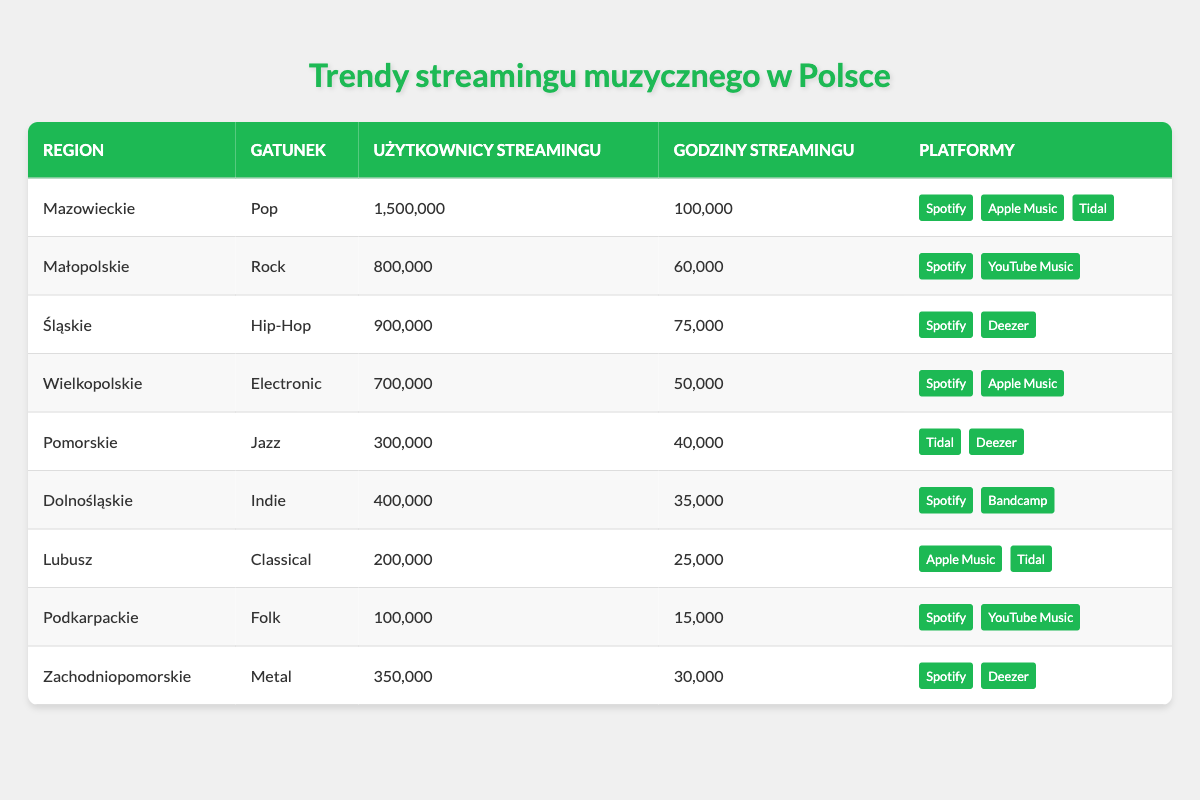What region has the highest number of streaming users? By examining the “Użytkownicy streamingu” column, I find that Mazowieckie has the highest count at 1,500,000 users.
Answer: Mazowieckie How many streaming hours are recorded for Rock music in Małopolskie? Looking at the “Godziny streamingu” column for the region Małopolskie and genre Rock, I see it has 60,000 streaming hours.
Answer: 60,000 What is the total number of streaming users across all regions for Electronic music? I check the table for the genre Electronic, which is found in Wielkopolskie, with 700,000 streaming users. There are no other regions with this genre. Thus, the total remains 700,000.
Answer: 700,000 Which genre has the least number of streaming users in the table? By reviewing the “Użytkownicy streamingu” column, the lowest count is for Folk music in Podkarpackie at 100,000 users.
Answer: Folk Are there more streaming hours for Indie music than for Jazz music? I compare the “Godziny streamingu” for Indie and Jazz genres. Indie has 35,000 hours while Jazz has 40,000 hours. Since 35,000 is less than 40,000, the answer is no.
Answer: No What is the total number of streaming users in the regions that have users for both Spotify and Deezer? The regions with both Spotify and Deezer are Śląskie (900,000) and Zachodniopomorskie (350,000). Adding these gives us 900,000 + 350,000 = 1,250,000 users.
Answer: 1,250,000 In which region do users spend the most hours streaming Pop music? Pop music is streamed in Mazowieckie only, and it accounts for 100,000 streaming hours, which is the highest among the genres listed.
Answer: Mazowieckie Is it true that all regions mentioned in the table have users that stream on Spotify? By scanning through the platforms for each region, I confirm that all regions either have Spotify listed or exclusively feature other platforms. Therefore, the statement is false as there are some regions without Spotify.
Answer: No What is the average number of streaming hours across all genres listed in the table? I sum the total streaming hours: 100,000 (Pop) + 60,000 (Rock) + 75,000 (Hip-Hop) + 50,000 (Electronic) + 40,000 (Jazz) + 35,000 (Indie) + 25,000 (Classical) + 15,000 (Folk) + 30,000 (Metal) = 410,000 hours. There are 9 genres, so the average is 410,000 / 9 = 45,555.56, which rounds down to 45,556.
Answer: 45,556 